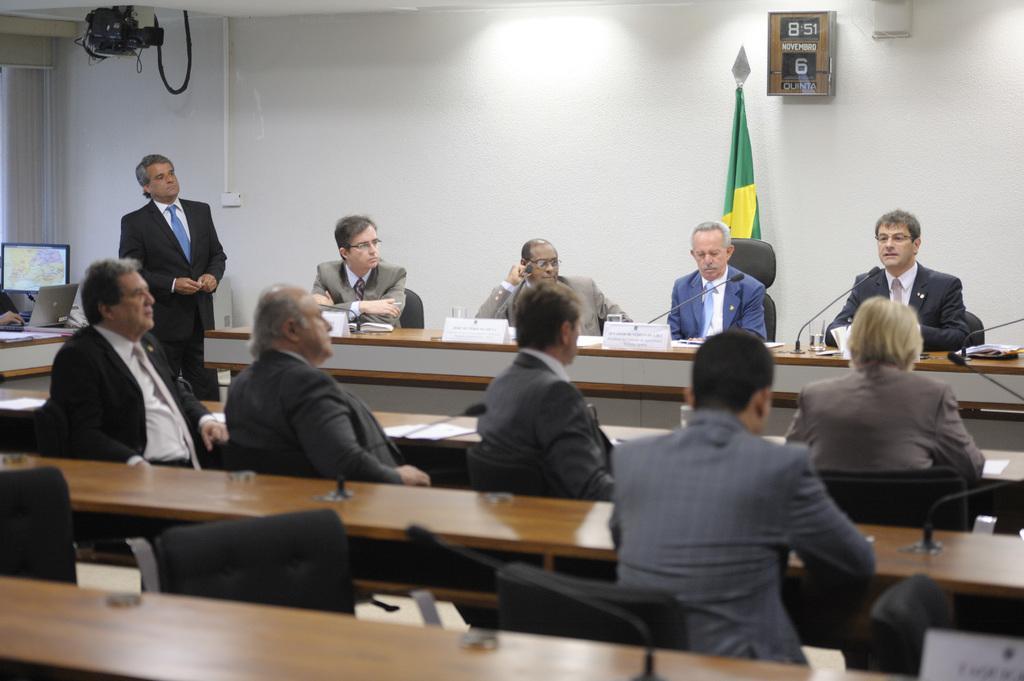In one or two sentences, can you explain what this image depicts? This picture shows a group of people seated on chair and we see papers and microphones on the table and we see a man standing and we see a monitor and a laptop on the table and we see a flag on the back 